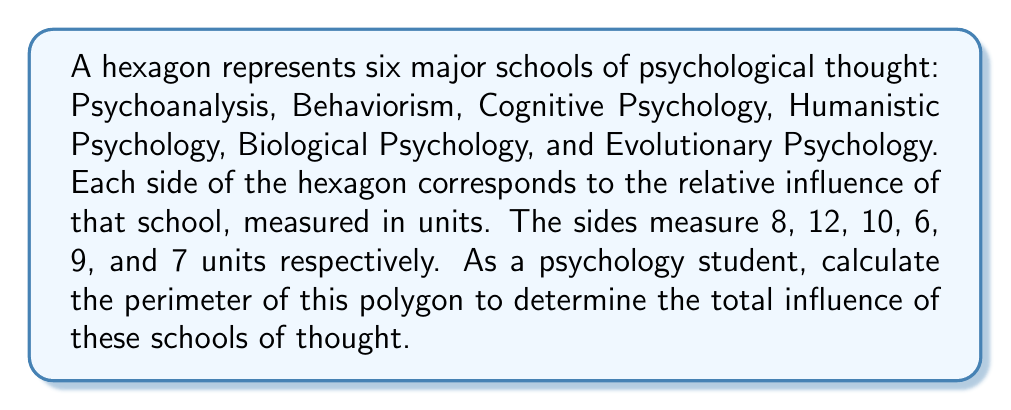Help me with this question. To solve this problem, we need to follow these steps:

1. Identify the given information:
   - The shape is a hexagon (6-sided polygon)
   - The side lengths are: 8, 12, 10, 6, 9, and 7 units

2. Recall the formula for the perimeter of a polygon:
   $$ P = \sum_{i=1}^{n} s_i $$
   Where $P$ is the perimeter, $n$ is the number of sides, and $s_i$ is the length of each side.

3. Sum up all the side lengths:
   $$ P = 8 + 12 + 10 + 6 + 9 + 7 $$

4. Perform the addition:
   $$ P = 52 $$

Therefore, the perimeter of the hexagon representing the six schools of psychological thought is 52 units.

[asy]
unitsize(10mm);
pair A = (0,0);
pair B = (8,0);
pair C = (14,6);
pair D = (10,14);
pair E = (2,14);
pair F = (-2,6);

draw(A--B--C--D--E--F--cycle);

label("8", (A+B)/2, S);
label("12", (B+C)/2, SE);
label("10", (C+D)/2, E);
label("6", (D+E)/2, N);
label("9", (E+F)/2, NW);
label("7", (F+A)/2, W);

label("Psychoanalysis", B, S);
label("Behaviorism", C, SE);
label("Cognitive", D, E);
label("Humanistic", E, N);
label("Biological", F, NW);
label("Evolutionary", A, SW);
[/asy]
Answer: 52 units 